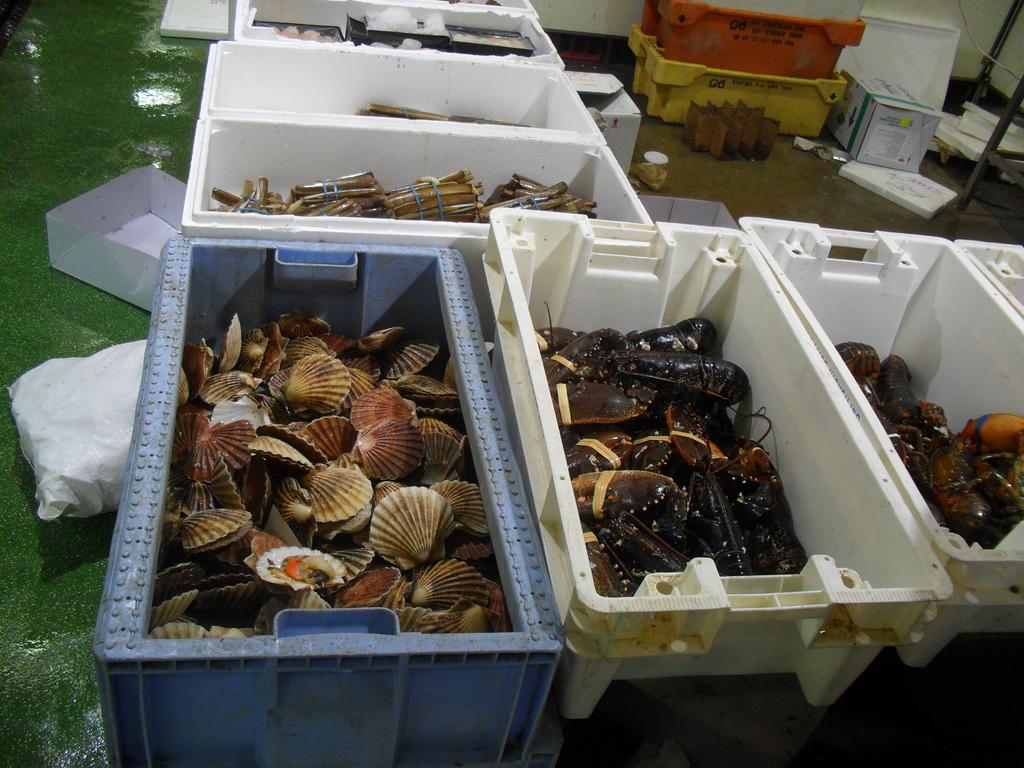What type of items are contained in the containers in the image? The containers hold seafood. What type of vegetation can be seen in the image? There is grass visible in the image. What is the shape of the box in the image? The information provided does not specify the shape of the box. What type of wire is present in the image? There is a cable wire in the image. Can you describe any other objects present in the image? There are other objects present in the image, but their specific details are not mentioned in the provided facts. What type of underwear is hanging on the cable wire in the image? There is no underwear present in the image; it only features containers holding seafood, grass, a box, and a cable wire. 